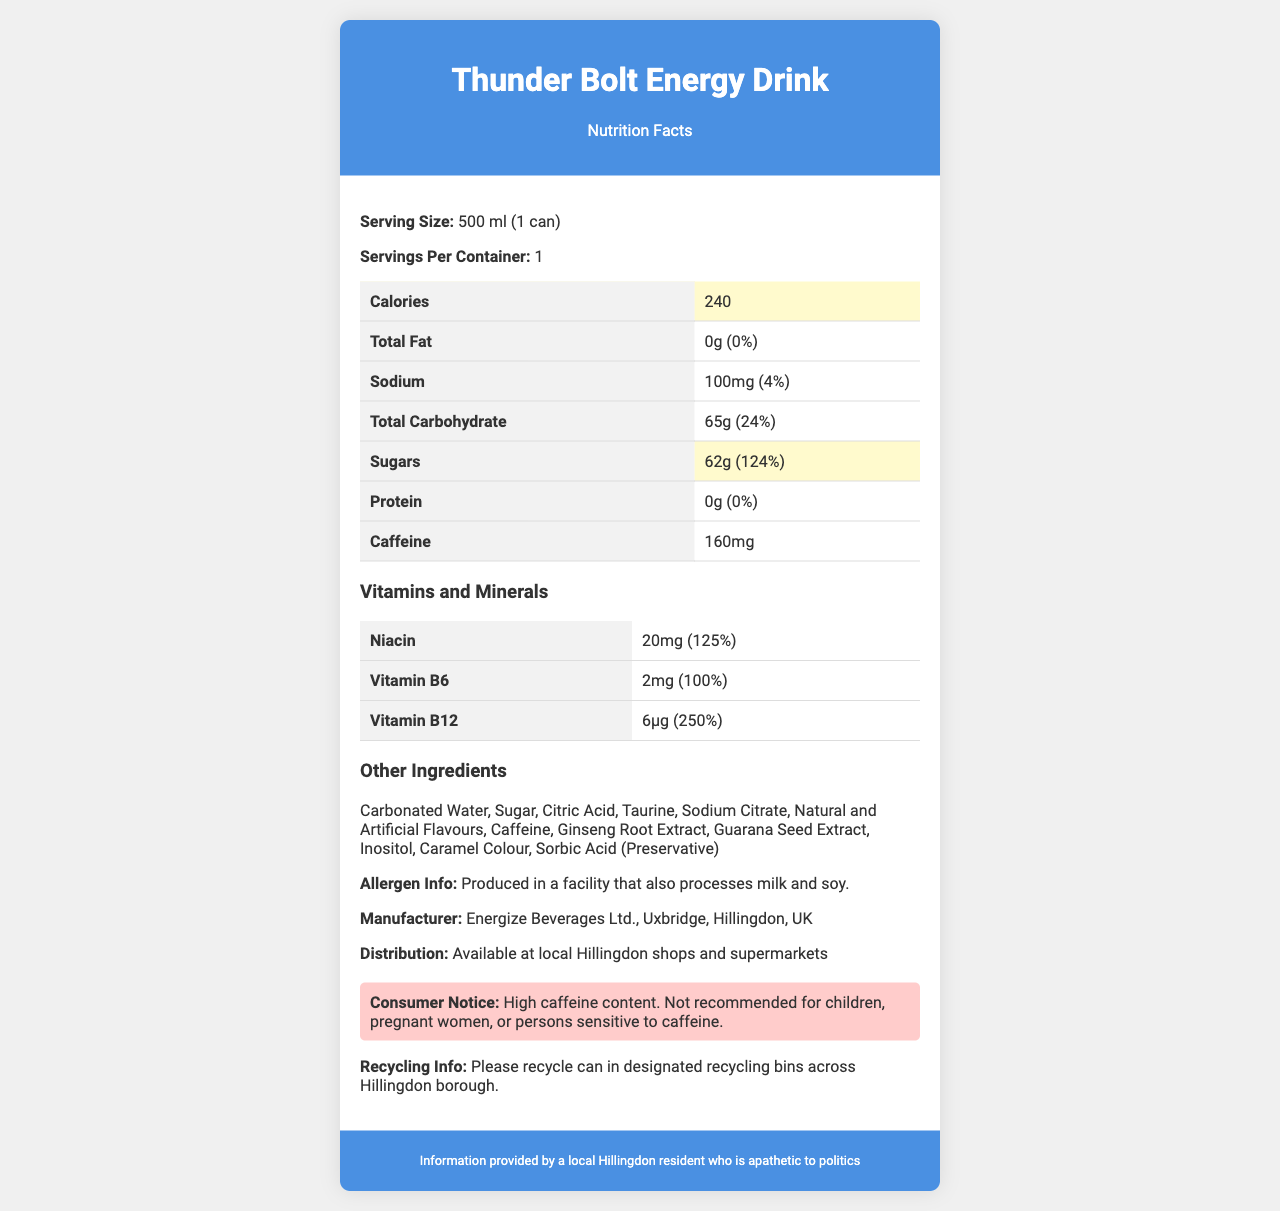What is the serving size of Thunder Bolt Energy Drink? The serving size is explicitly stated as "500 ml (1 can)" in the document.
Answer: 500 ml (1 can) How many calories are there per serving? The document lists that there are 240 calories per serving.
Answer: 240 What percentage of the daily value of sugars does Thunder Bolt Energy Drink contain? The drink contains 62g of sugars, which is 124% of the daily value.
Answer: 124% What is the caffeine content in Thunder Bolt Energy Drink? The caffeine content is listed as 160mg in the document.
Answer: 160mg Which vitamins are included in Thunder Bolt Energy Drink and their respective daily values? The document lists Niacin, Vitamin B6, and Vitamin B12 along with their respective daily values.
Answer: Niacin (125%), Vitamin B6 (100%), Vitamin B12 (250%) What is the sodium content and its percentage of the daily value? The document states that the sodium content is 100mg, which is 4% of the daily value.
Answer: 100mg, 4% Which ingredient is listed first in the "Other Ingredients" section? "Carbonated Water" is the first ingredient listed in the "Other Ingredients" section.
Answer: Carbonated Water Where is Thunder Bolt Energy Drink manufactured? The drink is manufactured by Energize Beverages Ltd., Uxbridge, Hillingdon, UK, as mentioned in the document.
Answer: Uxbridge, Hillingdon, UK Is Thunder Bolt Energy Drink suitable for children or pregnant women? The consumer notice specifically states that it is not recommended for children, pregnant women, or persons sensitive to caffeine.
Answer: No What is the main idea of this document? The document is structured to inform consumers about the nutritional composition, ingredients, and other relevant details about Thunder Bolt Energy Drink, ensuring they are aware of its contents and any precautions.
Answer: The document provides comprehensive nutritional information for Thunder Bolt Energy Drink, including serving size, calories, macro and micronutrients, caffeine content, other ingredients, allergen information, manufacturer details, and a consumer notice. Which of the following is not a vitamin listed in Thunder Bolt Energy Drink? A. Niacin B. Vitamin C C. Vitamin B6 D. Vitamin B12 Vitamin C is not listed among the vitamins in Thunder Bolt Energy Drink, while Niacin, Vitamin B6, and Vitamin B12 are included.
Answer: B What is the total carbohydrate content and its daily value percentage in Thunder Bolt Energy Drink? The total carbohydrate content is 65g, which represents 24% of the daily value.
Answer: 65g, 24% True or False: Thunder Bolt Energy Drink contains protein. The document states that the drink contains 0g of protein.
Answer: False What is the main source of sweetness in Thunder Bolt Energy Drink? The document lists "Sugar" as an ingredient and shows that the drink contains 62g of sugars.
Answer: Sugar Where can you recycle the Thunder Bolt Energy Drink can? The document advises recycling the can in designated recycling bins across the Hillingdon borough.
Answer: Designated recycling bins across Hillingdon borough Can you determine the price of Thunder Bolt Energy Drink from this document? The document does not provide any information about the price of the energy drink.
Answer: Cannot be determined 